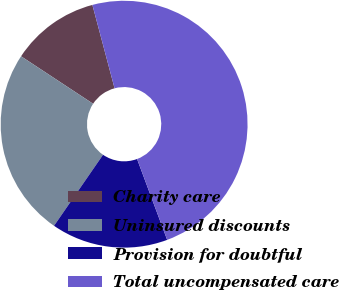Convert chart. <chart><loc_0><loc_0><loc_500><loc_500><pie_chart><fcel>Charity care<fcel>Uninsured discounts<fcel>Provision for doubtful<fcel>Total uncompensated care<nl><fcel>11.59%<fcel>24.66%<fcel>15.28%<fcel>48.46%<nl></chart> 